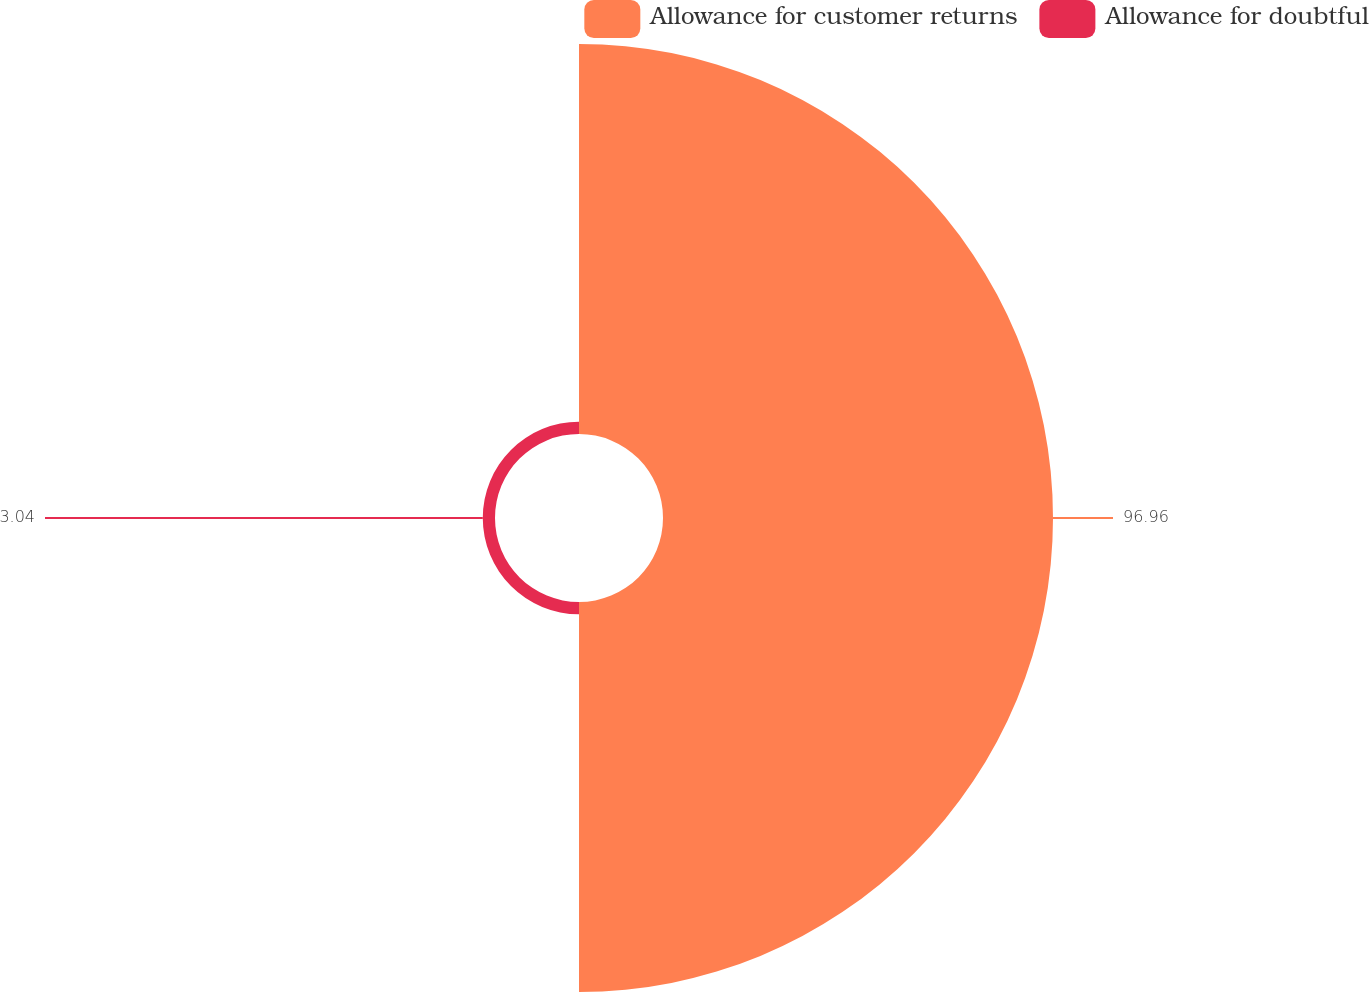Convert chart. <chart><loc_0><loc_0><loc_500><loc_500><pie_chart><fcel>Allowance for customer returns<fcel>Allowance for doubtful<nl><fcel>96.96%<fcel>3.04%<nl></chart> 